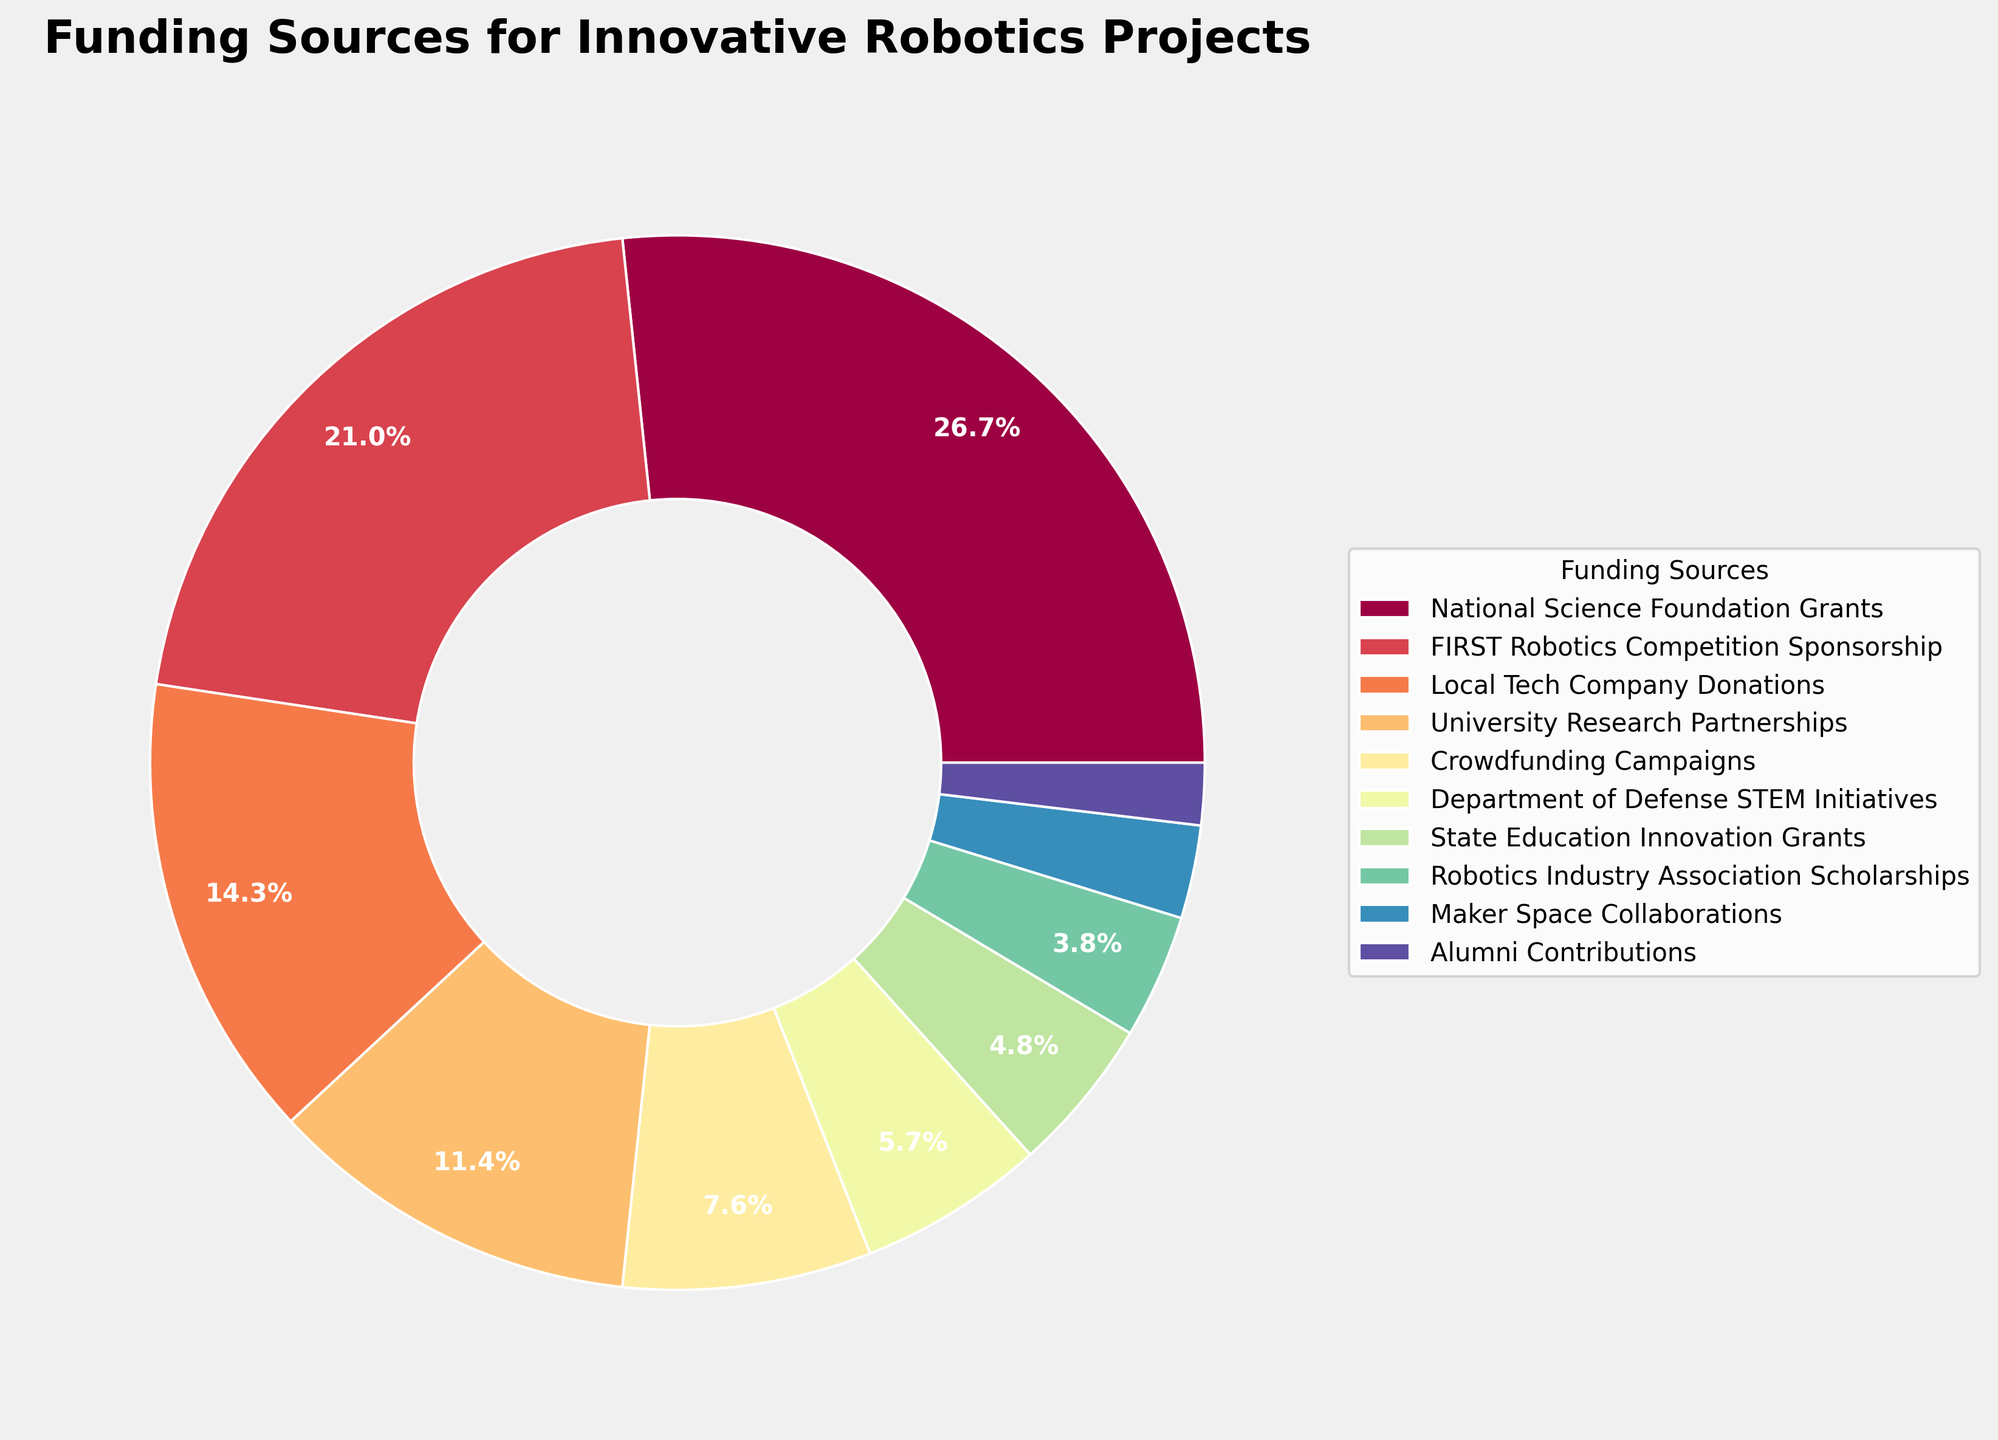Which funding source contributes the largest percentage? The largest wedge in the pie chart represents the National Science Foundation Grants at 28%.
Answer: National Science Foundation Grants What is the combined percentage of FIRST Robotics Competition Sponsorship and Local Tech Company Donations? Add the percentages of both funding sources: 22% (FIRST Robotics Competition Sponsorship) + 15% (Local Tech Company Donations) = 37%.
Answer: 37% Which funding source has a smaller percentage: Department of Defense STEM Initiatives or State Education Innovation Grants? Compare the percentages: Department of Defense STEM Initiatives is 6%, while State Education Innovation Grants is 5%. Hence, State Education Innovation Grants has the smaller percentage.
Answer: State Education Innovation Grants How many funding sources contribute less than 5% individually? Identify and count the segments that represent less than 5%. These are Robotics Industry Association Scholarships (4%), Maker Space Collaborations (3%), and Alumni Contributions (2%). So, there are 3.
Answer: 3 What is the percentage difference between the National Science Foundation Grants and the Robotics Industry Association Scholarships? Subtract the smaller percentage from the larger one: 28% - 4% = 24%.
Answer: 24% Which funding source is represented by the smallest wedge in the pie chart? The smallest wedge in the pie chart represents Alumni Contributions at 2%.
Answer: Alumni Contributions What's the total percentage of funding sources that individually contribute more than 10%? Identify those funding sources and add their percentages: National Science Foundation Grants (28%) + FIRST Robotics Competition Sponsorship (22%) + Local Tech Company Donations (15%) + University Research Partnerships (12%) = 77%.
Answer: 77% What visual attribute distinguishes the different funding sources in the pie chart besides size? The wedges are distinguished by different colors.
Answer: colors 